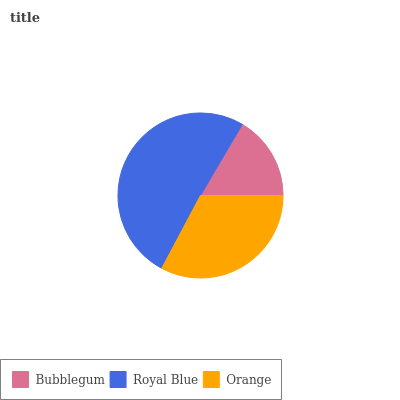Is Bubblegum the minimum?
Answer yes or no. Yes. Is Royal Blue the maximum?
Answer yes or no. Yes. Is Orange the minimum?
Answer yes or no. No. Is Orange the maximum?
Answer yes or no. No. Is Royal Blue greater than Orange?
Answer yes or no. Yes. Is Orange less than Royal Blue?
Answer yes or no. Yes. Is Orange greater than Royal Blue?
Answer yes or no. No. Is Royal Blue less than Orange?
Answer yes or no. No. Is Orange the high median?
Answer yes or no. Yes. Is Orange the low median?
Answer yes or no. Yes. Is Bubblegum the high median?
Answer yes or no. No. Is Bubblegum the low median?
Answer yes or no. No. 